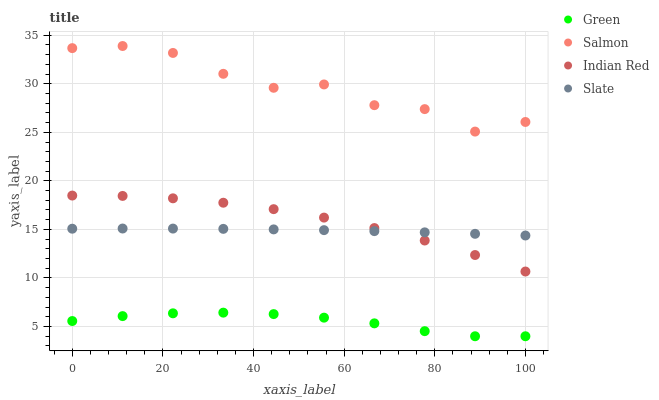Does Green have the minimum area under the curve?
Answer yes or no. Yes. Does Salmon have the maximum area under the curve?
Answer yes or no. Yes. Does Slate have the minimum area under the curve?
Answer yes or no. No. Does Slate have the maximum area under the curve?
Answer yes or no. No. Is Slate the smoothest?
Answer yes or no. Yes. Is Salmon the roughest?
Answer yes or no. Yes. Is Green the smoothest?
Answer yes or no. No. Is Green the roughest?
Answer yes or no. No. Does Green have the lowest value?
Answer yes or no. Yes. Does Slate have the lowest value?
Answer yes or no. No. Does Salmon have the highest value?
Answer yes or no. Yes. Does Slate have the highest value?
Answer yes or no. No. Is Green less than Slate?
Answer yes or no. Yes. Is Salmon greater than Indian Red?
Answer yes or no. Yes. Does Slate intersect Indian Red?
Answer yes or no. Yes. Is Slate less than Indian Red?
Answer yes or no. No. Is Slate greater than Indian Red?
Answer yes or no. No. Does Green intersect Slate?
Answer yes or no. No. 